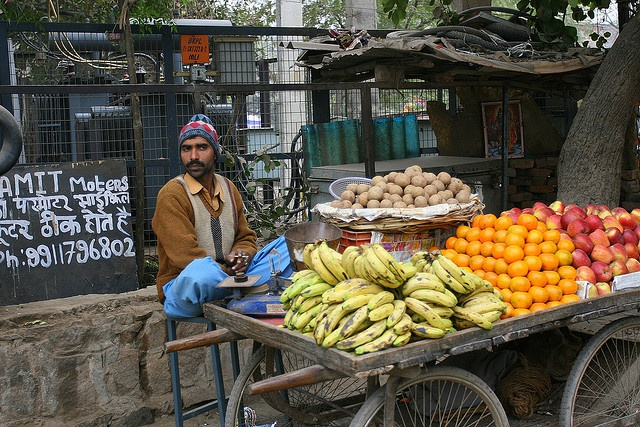Describe the objects in this image and their specific colors. I can see people in darkgreen, maroon, black, and lightblue tones, orange in darkgreen, orange, red, and gold tones, apple in darkgreen, salmon, tan, brown, and red tones, banana in darkgreen, khaki, tan, and olive tones, and banana in darkgreen, khaki, and olive tones in this image. 